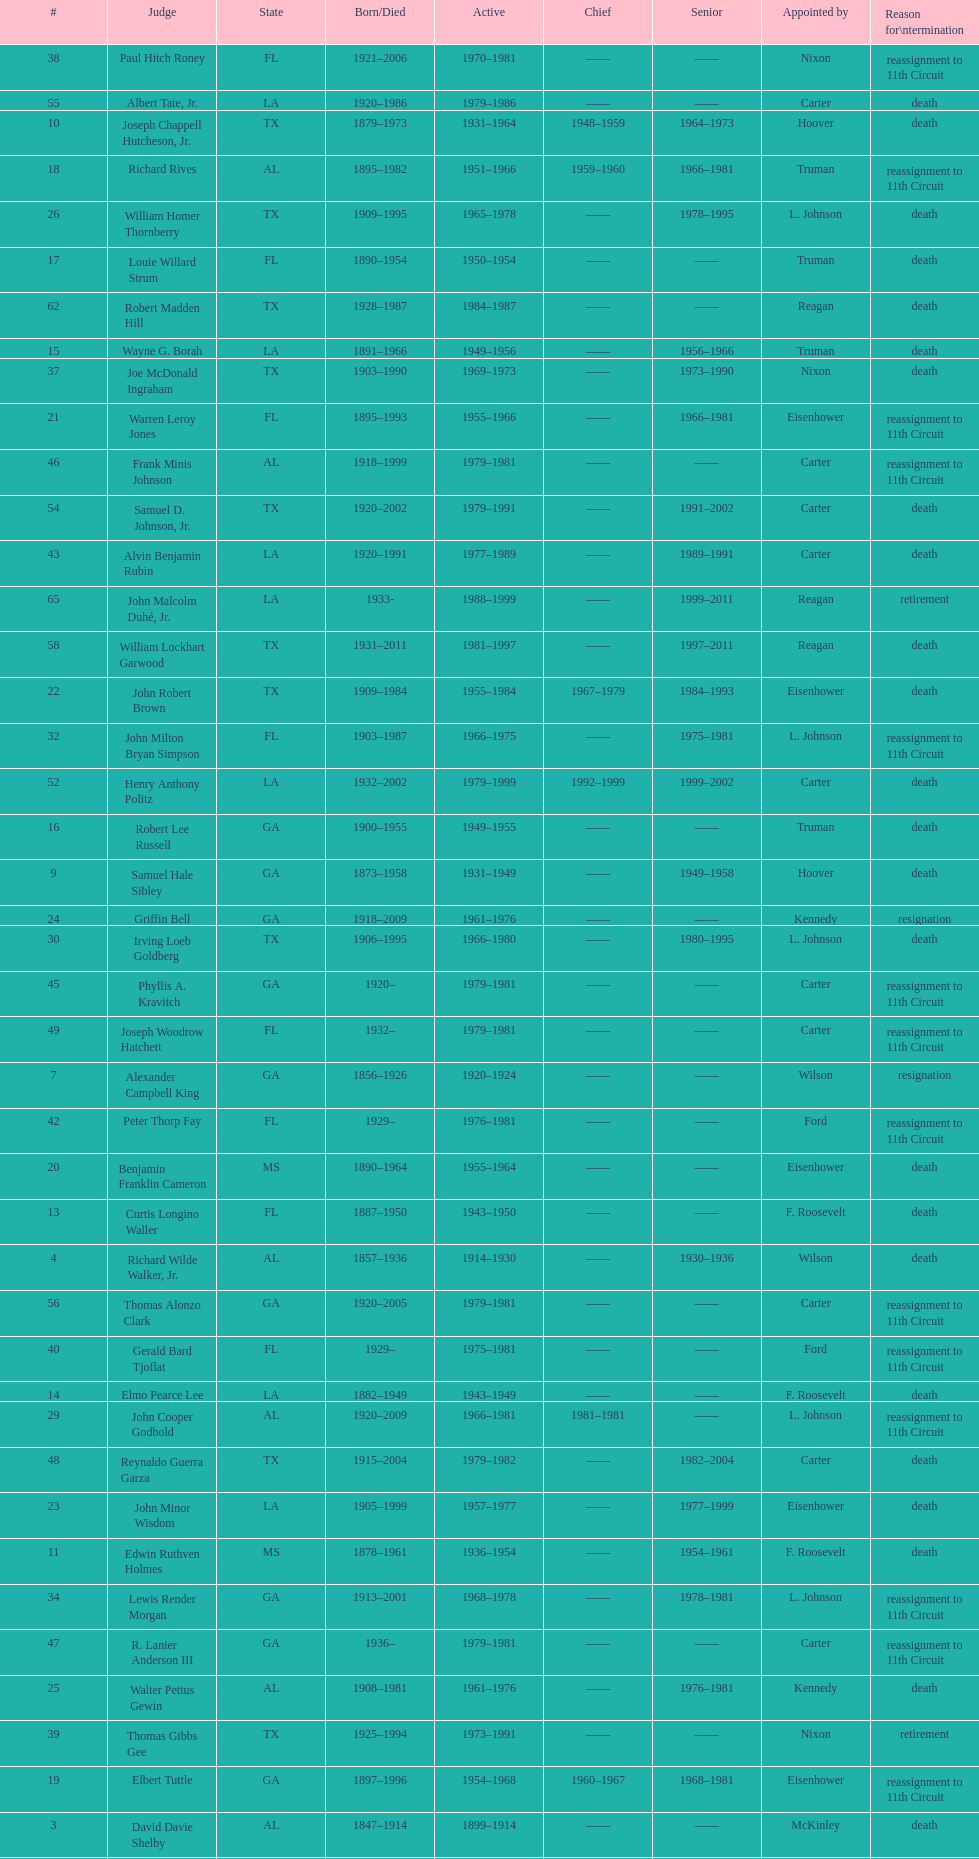How many judges served as chief total? 8. 